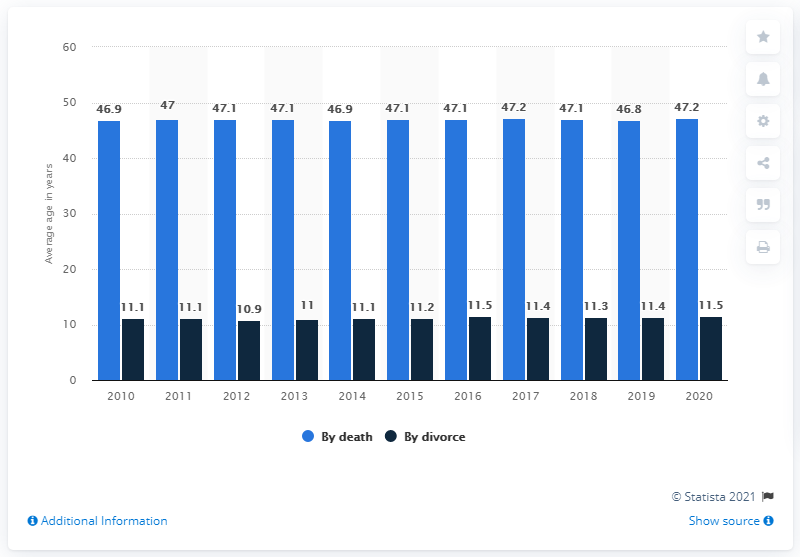Indicate a few pertinent items in this graphic. The average number of divorces between the years 2012 and 2015 is 10.05. According to data, in the year 2011, the average length of marriage before death was 47 years. 